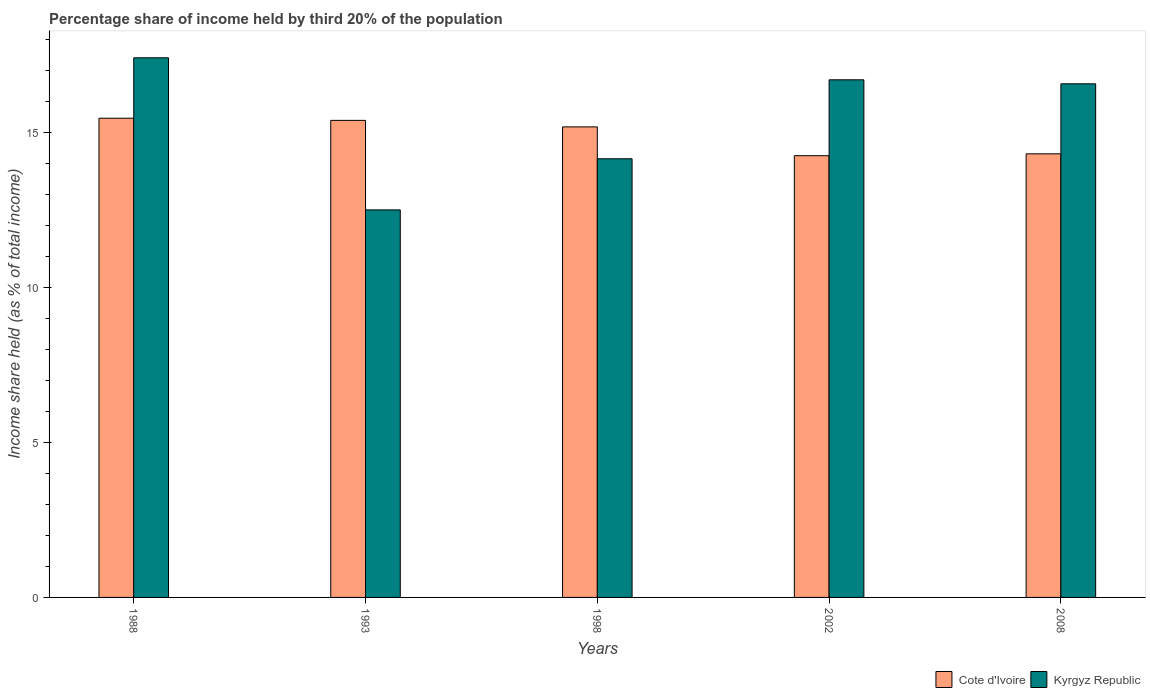How many different coloured bars are there?
Keep it short and to the point. 2. How many groups of bars are there?
Keep it short and to the point. 5. Are the number of bars per tick equal to the number of legend labels?
Keep it short and to the point. Yes. In how many cases, is the number of bars for a given year not equal to the number of legend labels?
Your answer should be compact. 0. What is the share of income held by third 20% of the population in Kyrgyz Republic in 2002?
Your response must be concise. 16.71. Across all years, what is the maximum share of income held by third 20% of the population in Kyrgyz Republic?
Your response must be concise. 17.42. Across all years, what is the minimum share of income held by third 20% of the population in Kyrgyz Republic?
Your answer should be very brief. 12.51. In which year was the share of income held by third 20% of the population in Kyrgyz Republic maximum?
Provide a short and direct response. 1988. In which year was the share of income held by third 20% of the population in Kyrgyz Republic minimum?
Offer a very short reply. 1993. What is the total share of income held by third 20% of the population in Cote d'Ivoire in the graph?
Provide a short and direct response. 74.64. What is the difference between the share of income held by third 20% of the population in Cote d'Ivoire in 1998 and that in 2008?
Make the answer very short. 0.87. What is the difference between the share of income held by third 20% of the population in Cote d'Ivoire in 1988 and the share of income held by third 20% of the population in Kyrgyz Republic in 2002?
Make the answer very short. -1.24. What is the average share of income held by third 20% of the population in Kyrgyz Republic per year?
Offer a terse response. 15.48. In the year 1998, what is the difference between the share of income held by third 20% of the population in Cote d'Ivoire and share of income held by third 20% of the population in Kyrgyz Republic?
Your answer should be compact. 1.03. What is the ratio of the share of income held by third 20% of the population in Cote d'Ivoire in 1993 to that in 1998?
Your response must be concise. 1.01. Is the share of income held by third 20% of the population in Cote d'Ivoire in 1993 less than that in 1998?
Ensure brevity in your answer.  No. Is the difference between the share of income held by third 20% of the population in Cote d'Ivoire in 1988 and 2008 greater than the difference between the share of income held by third 20% of the population in Kyrgyz Republic in 1988 and 2008?
Provide a succinct answer. Yes. What is the difference between the highest and the second highest share of income held by third 20% of the population in Kyrgyz Republic?
Your answer should be very brief. 0.71. What is the difference between the highest and the lowest share of income held by third 20% of the population in Cote d'Ivoire?
Offer a terse response. 1.21. Is the sum of the share of income held by third 20% of the population in Kyrgyz Republic in 1988 and 1998 greater than the maximum share of income held by third 20% of the population in Cote d'Ivoire across all years?
Offer a terse response. Yes. What does the 1st bar from the left in 2008 represents?
Make the answer very short. Cote d'Ivoire. What does the 1st bar from the right in 2008 represents?
Your response must be concise. Kyrgyz Republic. How many bars are there?
Give a very brief answer. 10. Are all the bars in the graph horizontal?
Give a very brief answer. No. How many years are there in the graph?
Your response must be concise. 5. What is the difference between two consecutive major ticks on the Y-axis?
Keep it short and to the point. 5. Are the values on the major ticks of Y-axis written in scientific E-notation?
Offer a very short reply. No. Does the graph contain any zero values?
Keep it short and to the point. No. Does the graph contain grids?
Your answer should be very brief. No. Where does the legend appear in the graph?
Keep it short and to the point. Bottom right. How are the legend labels stacked?
Your response must be concise. Horizontal. What is the title of the graph?
Your answer should be compact. Percentage share of income held by third 20% of the population. What is the label or title of the Y-axis?
Make the answer very short. Income share held (as % of total income). What is the Income share held (as % of total income) in Cote d'Ivoire in 1988?
Provide a succinct answer. 15.47. What is the Income share held (as % of total income) in Kyrgyz Republic in 1988?
Keep it short and to the point. 17.42. What is the Income share held (as % of total income) of Cote d'Ivoire in 1993?
Make the answer very short. 15.4. What is the Income share held (as % of total income) in Kyrgyz Republic in 1993?
Keep it short and to the point. 12.51. What is the Income share held (as % of total income) of Cote d'Ivoire in 1998?
Ensure brevity in your answer.  15.19. What is the Income share held (as % of total income) in Kyrgyz Republic in 1998?
Your answer should be compact. 14.16. What is the Income share held (as % of total income) of Cote d'Ivoire in 2002?
Offer a terse response. 14.26. What is the Income share held (as % of total income) in Kyrgyz Republic in 2002?
Provide a short and direct response. 16.71. What is the Income share held (as % of total income) of Cote d'Ivoire in 2008?
Offer a terse response. 14.32. What is the Income share held (as % of total income) of Kyrgyz Republic in 2008?
Provide a short and direct response. 16.58. Across all years, what is the maximum Income share held (as % of total income) in Cote d'Ivoire?
Offer a terse response. 15.47. Across all years, what is the maximum Income share held (as % of total income) of Kyrgyz Republic?
Give a very brief answer. 17.42. Across all years, what is the minimum Income share held (as % of total income) in Cote d'Ivoire?
Ensure brevity in your answer.  14.26. Across all years, what is the minimum Income share held (as % of total income) in Kyrgyz Republic?
Offer a very short reply. 12.51. What is the total Income share held (as % of total income) in Cote d'Ivoire in the graph?
Your answer should be very brief. 74.64. What is the total Income share held (as % of total income) of Kyrgyz Republic in the graph?
Ensure brevity in your answer.  77.38. What is the difference between the Income share held (as % of total income) in Cote d'Ivoire in 1988 and that in 1993?
Provide a short and direct response. 0.07. What is the difference between the Income share held (as % of total income) in Kyrgyz Republic in 1988 and that in 1993?
Give a very brief answer. 4.91. What is the difference between the Income share held (as % of total income) of Cote d'Ivoire in 1988 and that in 1998?
Your answer should be compact. 0.28. What is the difference between the Income share held (as % of total income) of Kyrgyz Republic in 1988 and that in 1998?
Your answer should be compact. 3.26. What is the difference between the Income share held (as % of total income) in Cote d'Ivoire in 1988 and that in 2002?
Provide a succinct answer. 1.21. What is the difference between the Income share held (as % of total income) of Kyrgyz Republic in 1988 and that in 2002?
Your answer should be compact. 0.71. What is the difference between the Income share held (as % of total income) in Cote d'Ivoire in 1988 and that in 2008?
Make the answer very short. 1.15. What is the difference between the Income share held (as % of total income) of Kyrgyz Republic in 1988 and that in 2008?
Keep it short and to the point. 0.84. What is the difference between the Income share held (as % of total income) of Cote d'Ivoire in 1993 and that in 1998?
Make the answer very short. 0.21. What is the difference between the Income share held (as % of total income) of Kyrgyz Republic in 1993 and that in 1998?
Keep it short and to the point. -1.65. What is the difference between the Income share held (as % of total income) in Cote d'Ivoire in 1993 and that in 2002?
Give a very brief answer. 1.14. What is the difference between the Income share held (as % of total income) of Kyrgyz Republic in 1993 and that in 2002?
Your answer should be very brief. -4.2. What is the difference between the Income share held (as % of total income) in Kyrgyz Republic in 1993 and that in 2008?
Provide a short and direct response. -4.07. What is the difference between the Income share held (as % of total income) in Kyrgyz Republic in 1998 and that in 2002?
Offer a terse response. -2.55. What is the difference between the Income share held (as % of total income) in Cote d'Ivoire in 1998 and that in 2008?
Provide a succinct answer. 0.87. What is the difference between the Income share held (as % of total income) of Kyrgyz Republic in 1998 and that in 2008?
Offer a very short reply. -2.42. What is the difference between the Income share held (as % of total income) in Cote d'Ivoire in 2002 and that in 2008?
Ensure brevity in your answer.  -0.06. What is the difference between the Income share held (as % of total income) of Kyrgyz Republic in 2002 and that in 2008?
Keep it short and to the point. 0.13. What is the difference between the Income share held (as % of total income) of Cote d'Ivoire in 1988 and the Income share held (as % of total income) of Kyrgyz Republic in 1993?
Make the answer very short. 2.96. What is the difference between the Income share held (as % of total income) in Cote d'Ivoire in 1988 and the Income share held (as % of total income) in Kyrgyz Republic in 1998?
Ensure brevity in your answer.  1.31. What is the difference between the Income share held (as % of total income) in Cote d'Ivoire in 1988 and the Income share held (as % of total income) in Kyrgyz Republic in 2002?
Offer a very short reply. -1.24. What is the difference between the Income share held (as % of total income) in Cote d'Ivoire in 1988 and the Income share held (as % of total income) in Kyrgyz Republic in 2008?
Your answer should be very brief. -1.11. What is the difference between the Income share held (as % of total income) of Cote d'Ivoire in 1993 and the Income share held (as % of total income) of Kyrgyz Republic in 1998?
Offer a very short reply. 1.24. What is the difference between the Income share held (as % of total income) in Cote d'Ivoire in 1993 and the Income share held (as % of total income) in Kyrgyz Republic in 2002?
Your answer should be compact. -1.31. What is the difference between the Income share held (as % of total income) in Cote d'Ivoire in 1993 and the Income share held (as % of total income) in Kyrgyz Republic in 2008?
Make the answer very short. -1.18. What is the difference between the Income share held (as % of total income) in Cote d'Ivoire in 1998 and the Income share held (as % of total income) in Kyrgyz Republic in 2002?
Offer a terse response. -1.52. What is the difference between the Income share held (as % of total income) in Cote d'Ivoire in 1998 and the Income share held (as % of total income) in Kyrgyz Republic in 2008?
Your answer should be very brief. -1.39. What is the difference between the Income share held (as % of total income) of Cote d'Ivoire in 2002 and the Income share held (as % of total income) of Kyrgyz Republic in 2008?
Make the answer very short. -2.32. What is the average Income share held (as % of total income) of Cote d'Ivoire per year?
Give a very brief answer. 14.93. What is the average Income share held (as % of total income) of Kyrgyz Republic per year?
Make the answer very short. 15.48. In the year 1988, what is the difference between the Income share held (as % of total income) of Cote d'Ivoire and Income share held (as % of total income) of Kyrgyz Republic?
Offer a very short reply. -1.95. In the year 1993, what is the difference between the Income share held (as % of total income) of Cote d'Ivoire and Income share held (as % of total income) of Kyrgyz Republic?
Offer a terse response. 2.89. In the year 1998, what is the difference between the Income share held (as % of total income) in Cote d'Ivoire and Income share held (as % of total income) in Kyrgyz Republic?
Keep it short and to the point. 1.03. In the year 2002, what is the difference between the Income share held (as % of total income) of Cote d'Ivoire and Income share held (as % of total income) of Kyrgyz Republic?
Offer a terse response. -2.45. In the year 2008, what is the difference between the Income share held (as % of total income) of Cote d'Ivoire and Income share held (as % of total income) of Kyrgyz Republic?
Give a very brief answer. -2.26. What is the ratio of the Income share held (as % of total income) of Cote d'Ivoire in 1988 to that in 1993?
Your answer should be compact. 1. What is the ratio of the Income share held (as % of total income) in Kyrgyz Republic in 1988 to that in 1993?
Give a very brief answer. 1.39. What is the ratio of the Income share held (as % of total income) in Cote d'Ivoire in 1988 to that in 1998?
Your answer should be very brief. 1.02. What is the ratio of the Income share held (as % of total income) of Kyrgyz Republic in 1988 to that in 1998?
Give a very brief answer. 1.23. What is the ratio of the Income share held (as % of total income) of Cote d'Ivoire in 1988 to that in 2002?
Give a very brief answer. 1.08. What is the ratio of the Income share held (as % of total income) in Kyrgyz Republic in 1988 to that in 2002?
Give a very brief answer. 1.04. What is the ratio of the Income share held (as % of total income) in Cote d'Ivoire in 1988 to that in 2008?
Offer a terse response. 1.08. What is the ratio of the Income share held (as % of total income) of Kyrgyz Republic in 1988 to that in 2008?
Give a very brief answer. 1.05. What is the ratio of the Income share held (as % of total income) of Cote d'Ivoire in 1993 to that in 1998?
Offer a terse response. 1.01. What is the ratio of the Income share held (as % of total income) in Kyrgyz Republic in 1993 to that in 1998?
Provide a short and direct response. 0.88. What is the ratio of the Income share held (as % of total income) in Cote d'Ivoire in 1993 to that in 2002?
Make the answer very short. 1.08. What is the ratio of the Income share held (as % of total income) in Kyrgyz Republic in 1993 to that in 2002?
Your response must be concise. 0.75. What is the ratio of the Income share held (as % of total income) of Cote d'Ivoire in 1993 to that in 2008?
Provide a succinct answer. 1.08. What is the ratio of the Income share held (as % of total income) in Kyrgyz Republic in 1993 to that in 2008?
Give a very brief answer. 0.75. What is the ratio of the Income share held (as % of total income) of Cote d'Ivoire in 1998 to that in 2002?
Give a very brief answer. 1.07. What is the ratio of the Income share held (as % of total income) in Kyrgyz Republic in 1998 to that in 2002?
Provide a short and direct response. 0.85. What is the ratio of the Income share held (as % of total income) of Cote d'Ivoire in 1998 to that in 2008?
Your answer should be very brief. 1.06. What is the ratio of the Income share held (as % of total income) in Kyrgyz Republic in 1998 to that in 2008?
Offer a very short reply. 0.85. What is the ratio of the Income share held (as % of total income) in Kyrgyz Republic in 2002 to that in 2008?
Give a very brief answer. 1.01. What is the difference between the highest and the second highest Income share held (as % of total income) in Cote d'Ivoire?
Offer a very short reply. 0.07. What is the difference between the highest and the second highest Income share held (as % of total income) of Kyrgyz Republic?
Your response must be concise. 0.71. What is the difference between the highest and the lowest Income share held (as % of total income) of Cote d'Ivoire?
Your answer should be compact. 1.21. What is the difference between the highest and the lowest Income share held (as % of total income) in Kyrgyz Republic?
Provide a short and direct response. 4.91. 